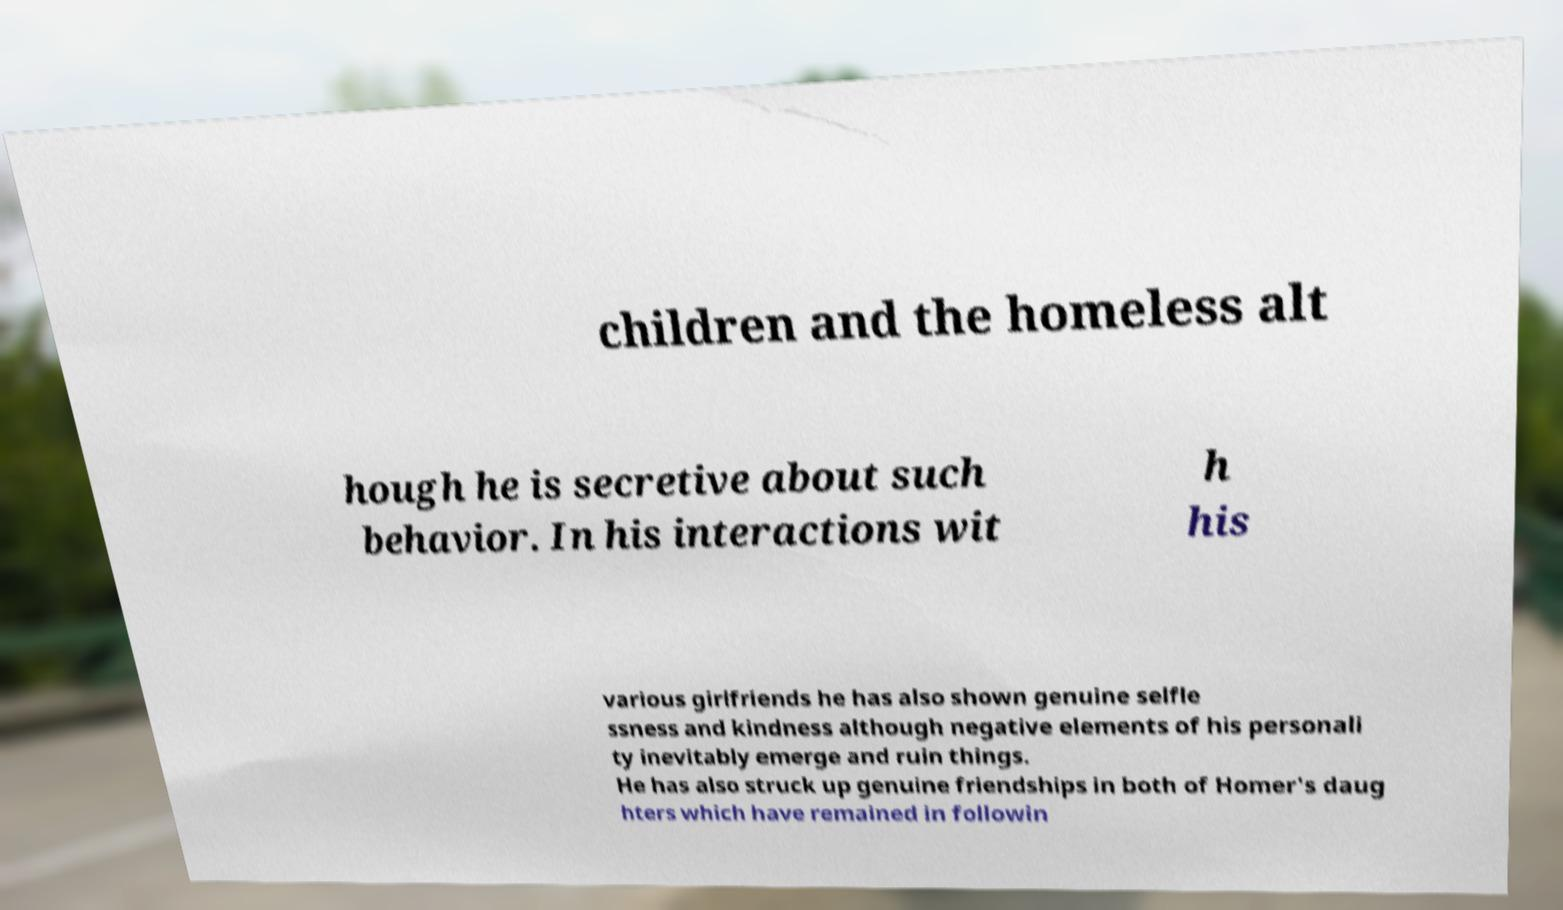What messages or text are displayed in this image? I need them in a readable, typed format. children and the homeless alt hough he is secretive about such behavior. In his interactions wit h his various girlfriends he has also shown genuine selfle ssness and kindness although negative elements of his personali ty inevitably emerge and ruin things. He has also struck up genuine friendships in both of Homer's daug hters which have remained in followin 